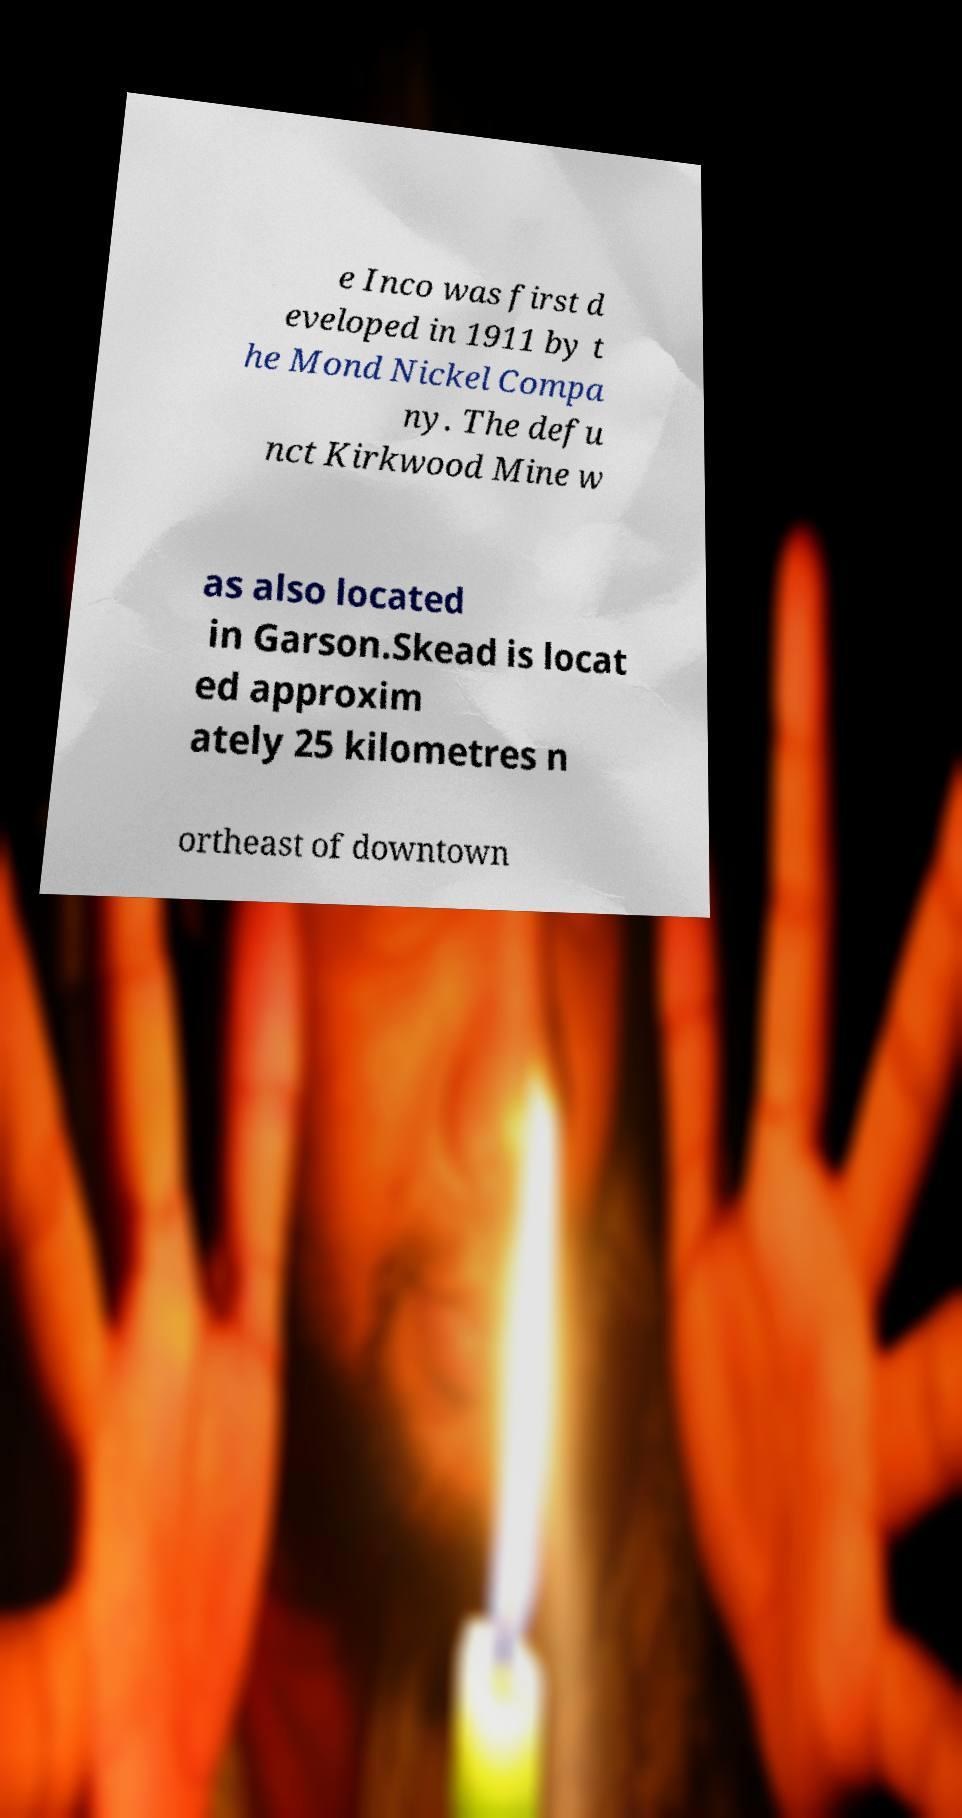Can you read and provide the text displayed in the image?This photo seems to have some interesting text. Can you extract and type it out for me? e Inco was first d eveloped in 1911 by t he Mond Nickel Compa ny. The defu nct Kirkwood Mine w as also located in Garson.Skead is locat ed approxim ately 25 kilometres n ortheast of downtown 